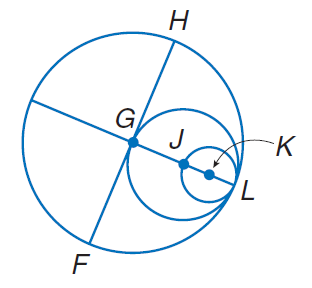Answer the mathemtical geometry problem and directly provide the correct option letter.
Question: Circles G, J, and K all intersect at L. If G H = 10. Find G J.
Choices: A: 5 B: 10 C: 20 D: 25 A 